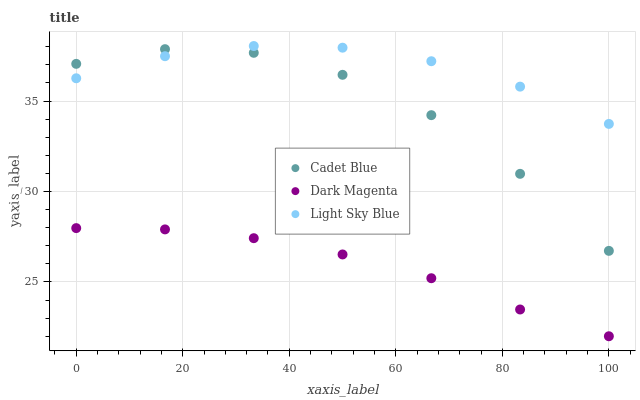Does Dark Magenta have the minimum area under the curve?
Answer yes or no. Yes. Does Light Sky Blue have the maximum area under the curve?
Answer yes or no. Yes. Does Light Sky Blue have the minimum area under the curve?
Answer yes or no. No. Does Dark Magenta have the maximum area under the curve?
Answer yes or no. No. Is Dark Magenta the smoothest?
Answer yes or no. Yes. Is Cadet Blue the roughest?
Answer yes or no. Yes. Is Light Sky Blue the smoothest?
Answer yes or no. No. Is Light Sky Blue the roughest?
Answer yes or no. No. Does Dark Magenta have the lowest value?
Answer yes or no. Yes. Does Light Sky Blue have the lowest value?
Answer yes or no. No. Does Light Sky Blue have the highest value?
Answer yes or no. Yes. Does Dark Magenta have the highest value?
Answer yes or no. No. Is Dark Magenta less than Cadet Blue?
Answer yes or no. Yes. Is Cadet Blue greater than Dark Magenta?
Answer yes or no. Yes. Does Cadet Blue intersect Light Sky Blue?
Answer yes or no. Yes. Is Cadet Blue less than Light Sky Blue?
Answer yes or no. No. Is Cadet Blue greater than Light Sky Blue?
Answer yes or no. No. Does Dark Magenta intersect Cadet Blue?
Answer yes or no. No. 